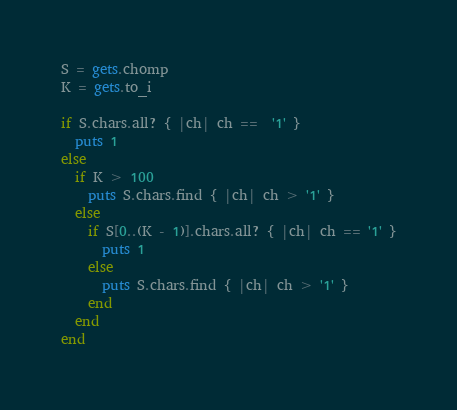Convert code to text. <code><loc_0><loc_0><loc_500><loc_500><_Ruby_>S = gets.chomp
K = gets.to_i

if S.chars.all? { |ch| ch ==  '1' }
  puts 1
else
  if K > 100
    puts S.chars.find { |ch| ch > '1' }
  else
    if S[0..(K - 1)].chars.all? { |ch| ch == '1' }
      puts 1
    else
      puts S.chars.find { |ch| ch > '1' }
    end
  end
end
</code> 